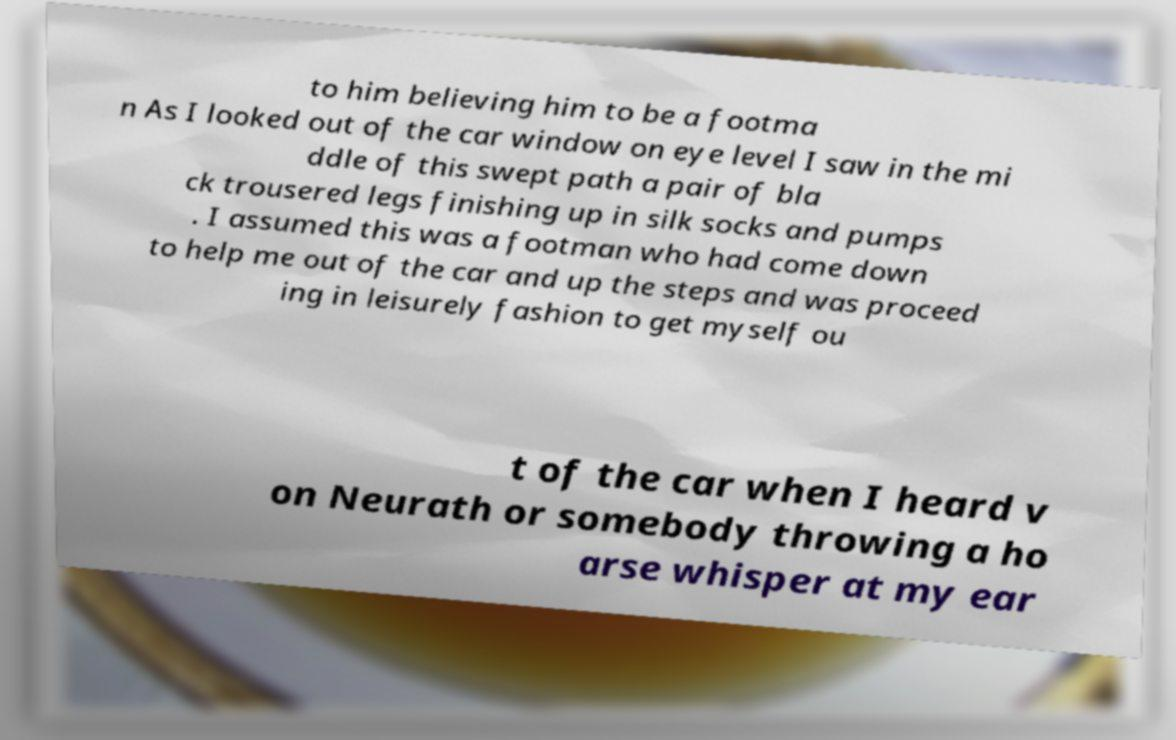Could you assist in decoding the text presented in this image and type it out clearly? to him believing him to be a footma n As I looked out of the car window on eye level I saw in the mi ddle of this swept path a pair of bla ck trousered legs finishing up in silk socks and pumps . I assumed this was a footman who had come down to help me out of the car and up the steps and was proceed ing in leisurely fashion to get myself ou t of the car when I heard v on Neurath or somebody throwing a ho arse whisper at my ear 